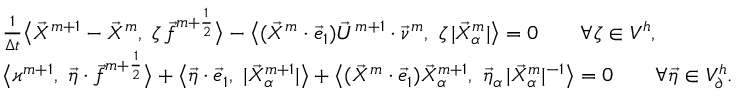<formula> <loc_0><loc_0><loc_500><loc_500>\begin{array} { r l } & { \frac { 1 } { \Delta t } \Big < \vec { X } ^ { m + 1 } - \vec { X } ^ { m } , \zeta \, \vec { f } ^ { m + \frac { 1 } { 2 } } \Big > - \Big < ( \vec { X } ^ { m } \cdot \vec { e } _ { 1 } ) \vec { U } ^ { m + 1 } \cdot \vec { \nu } ^ { m } , \zeta \, | \vec { X } _ { \alpha } ^ { m } | \Big > = 0 \quad \forall \zeta \in V ^ { h } , } \\ & { \Big < \varkappa ^ { m + 1 } , \vec { \eta } \cdot \vec { f } ^ { m + \frac { 1 } { 2 } } \Big > + \Big < \vec { \eta } \cdot \vec { e } _ { 1 } , | \vec { X } _ { \alpha } ^ { m + 1 } | \Big > + \Big < ( \vec { X } ^ { m } \cdot \vec { e } _ { 1 } ) \vec { X } _ { \alpha } ^ { m + 1 } , \vec { \eta } _ { \alpha } \, | \vec { X } _ { \alpha } ^ { m } | ^ { - 1 } \Big > = 0 \quad \forall \vec { \eta } \in V _ { \partial } ^ { h } . } \end{array}</formula> 